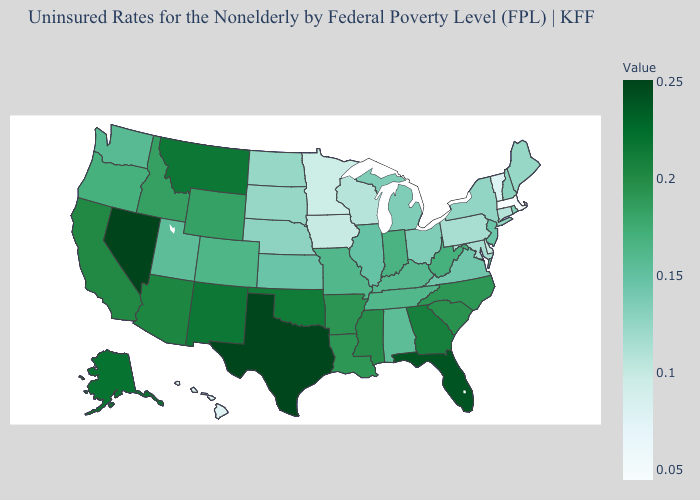Does the map have missing data?
Quick response, please. No. Among the states that border Idaho , does Nevada have the highest value?
Be succinct. Yes. Which states have the lowest value in the West?
Keep it brief. Hawaii. Does Indiana have the highest value in the MidWest?
Concise answer only. Yes. 